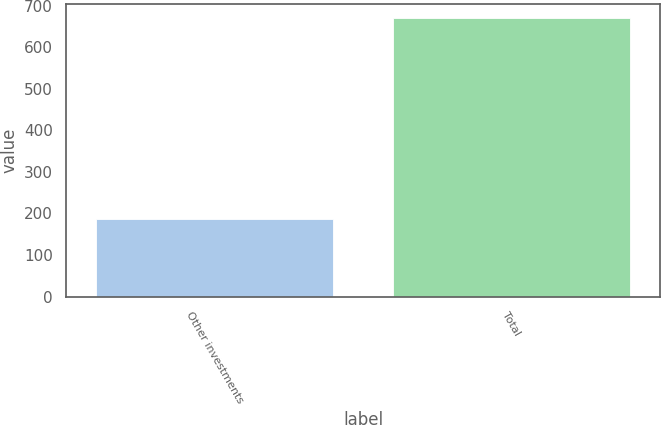<chart> <loc_0><loc_0><loc_500><loc_500><bar_chart><fcel>Other investments<fcel>Total<nl><fcel>187<fcel>670<nl></chart> 